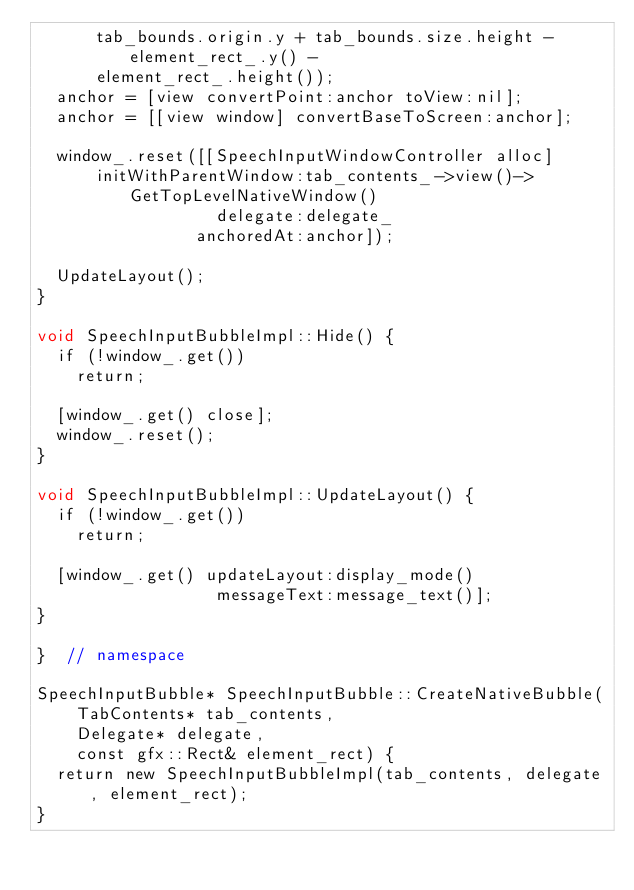<code> <loc_0><loc_0><loc_500><loc_500><_ObjectiveC_>      tab_bounds.origin.y + tab_bounds.size.height - element_rect_.y() -
      element_rect_.height());
  anchor = [view convertPoint:anchor toView:nil];
  anchor = [[view window] convertBaseToScreen:anchor];

  window_.reset([[SpeechInputWindowController alloc]
      initWithParentWindow:tab_contents_->view()->GetTopLevelNativeWindow()
                  delegate:delegate_
                anchoredAt:anchor]);

  UpdateLayout();
}

void SpeechInputBubbleImpl::Hide() {
  if (!window_.get())
    return;

  [window_.get() close];
  window_.reset();
}

void SpeechInputBubbleImpl::UpdateLayout() {
  if (!window_.get())
    return;

  [window_.get() updateLayout:display_mode()
                  messageText:message_text()];
}

}  // namespace

SpeechInputBubble* SpeechInputBubble::CreateNativeBubble(
    TabContents* tab_contents,
    Delegate* delegate,
    const gfx::Rect& element_rect) {
  return new SpeechInputBubbleImpl(tab_contents, delegate, element_rect);
}

</code> 